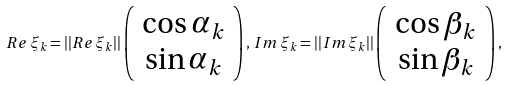<formula> <loc_0><loc_0><loc_500><loc_500>R e \, \xi _ { k } = | | R e \, \xi _ { k } | | \left ( \begin{array} { c } \cos \alpha _ { k } \\ \sin \alpha _ { k } \end{array} \right ) , \, I m \, \xi _ { k } = | | I m \, \xi _ { k } | | \left ( \begin{array} { c } \cos \beta _ { k } \\ \sin \beta _ { k } \end{array} \right ) ,</formula> 